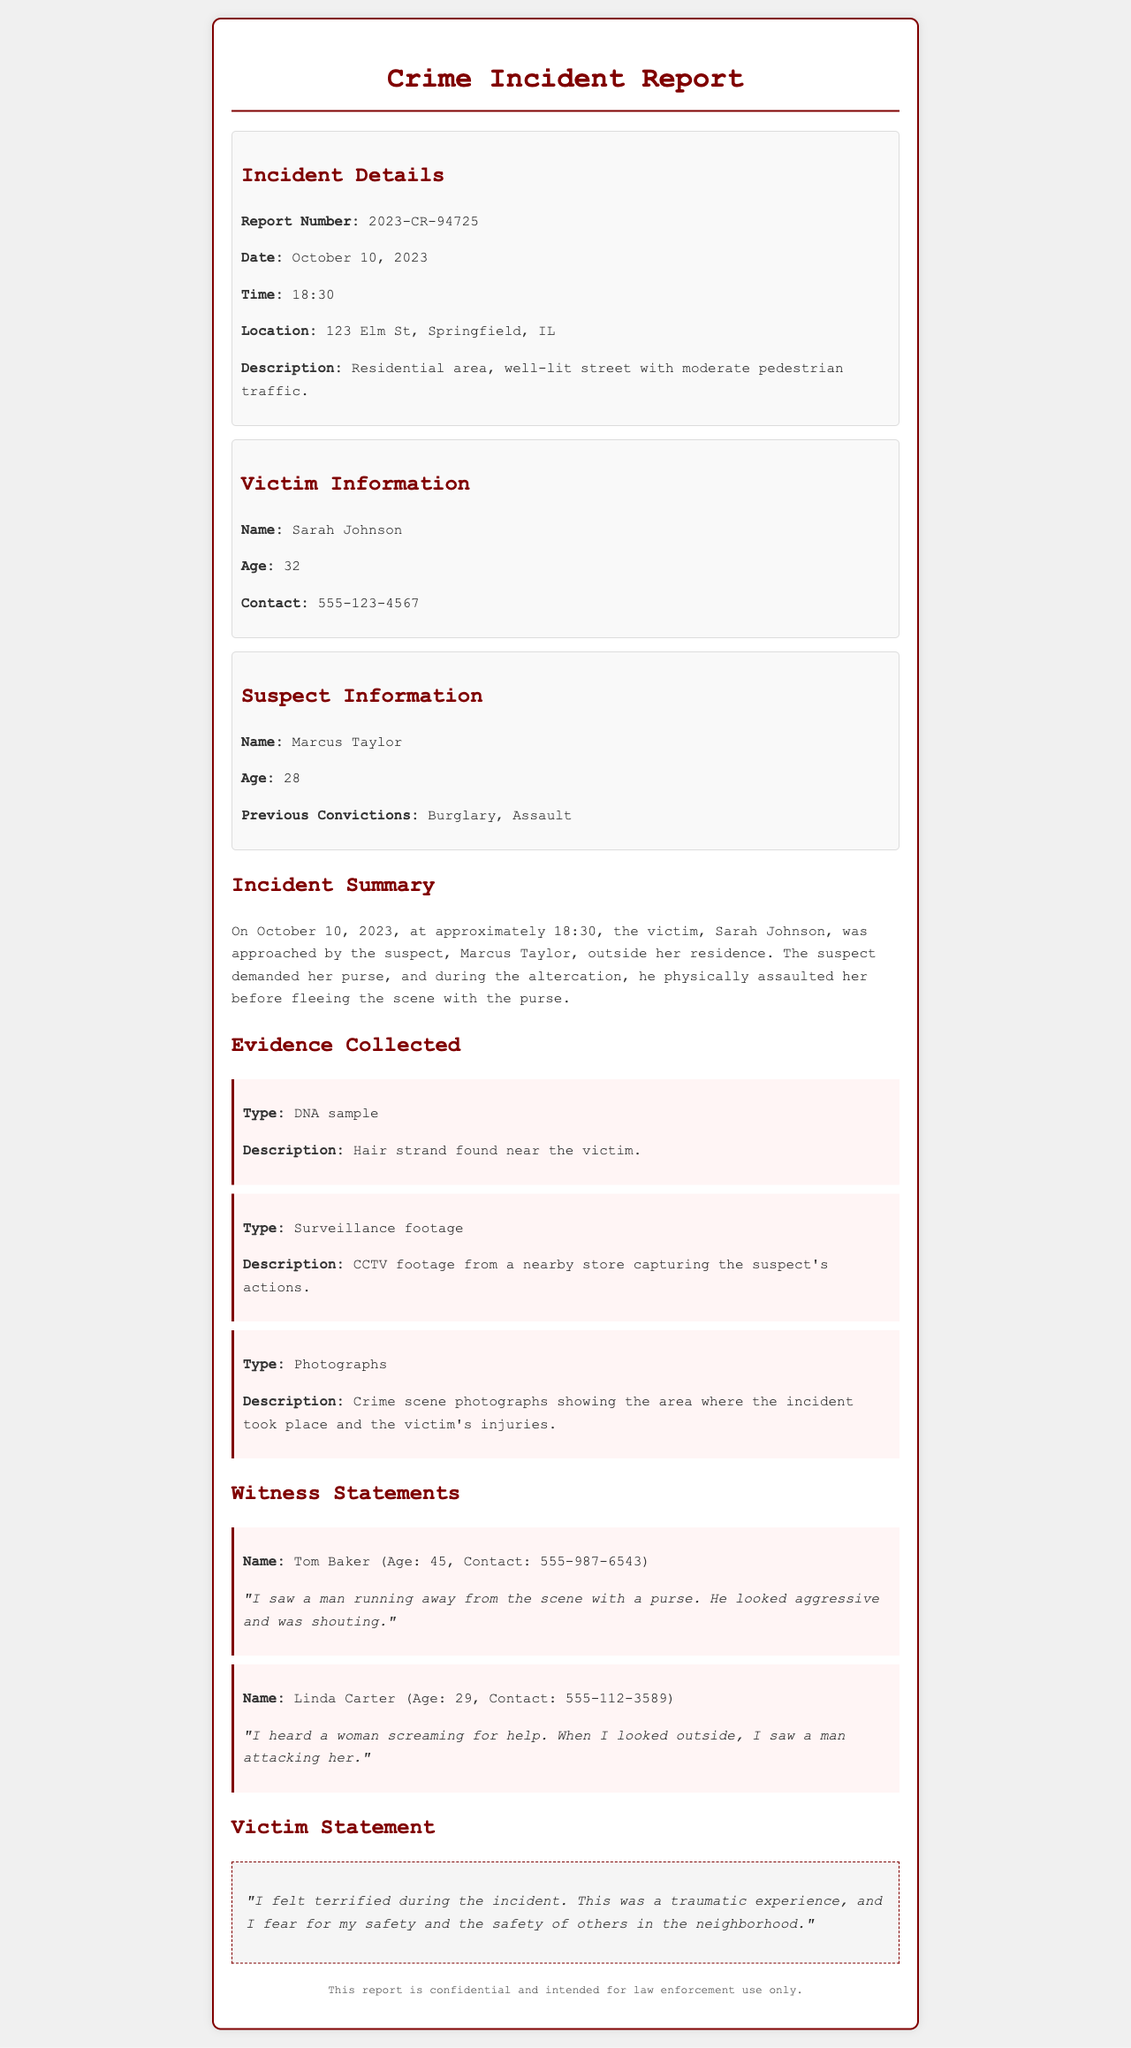What is the report number? The report number is a unique identifier for the document provided in the incident details section.
Answer: 2023-CR-94725 Who is the victim? The victim's name is stated in the victim information section and is a key detail of the report.
Answer: Sarah Johnson What type of evidence was collected? The evidence collected includes various types such as DNA, surveillance footage, and photographs mentioned in the evidence section.
Answer: DNA sample What did the witness, Tom Baker, see? Tom Baker's witness statement describes what he witnessed during the incident, reflecting his observation of the suspect.
Answer: A man running away from the scene What is the age of the suspect? The age of the suspect is mentioned in the suspect information section of the document.
Answer: 28 What location did the incident occur? The location is specified in the incident details, providing a geographic context for the crime.
Answer: 123 Elm St, Springfield, IL How did the victim feel during the incident? The victim's statement reflects her emotional response and experience during the crime, offering insight into the impact of the incident.
Answer: Terrified How many witnesses are listed in the report? The number of witnesses is determined by counting the witness statements included in the document.
Answer: Two What previous convictions does the suspect have? The previous convictions of the suspect are significant for understanding his criminal history, which is provided in the suspect information.
Answer: Burglary, Assault 